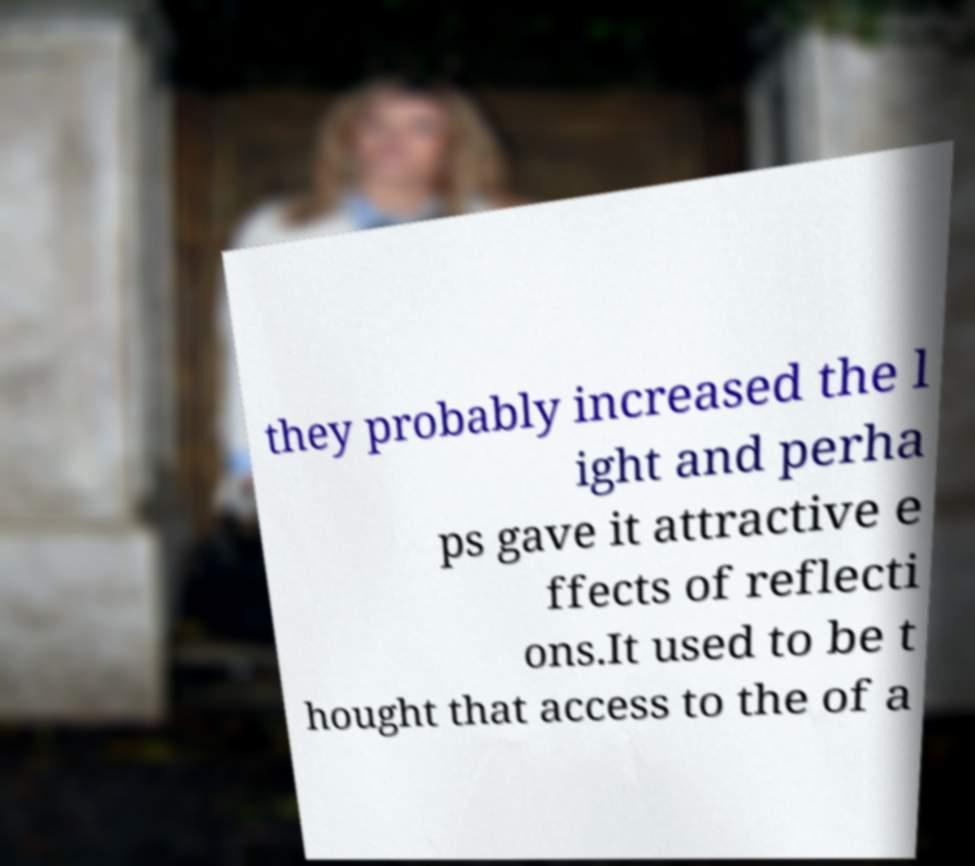Can you read and provide the text displayed in the image?This photo seems to have some interesting text. Can you extract and type it out for me? they probably increased the l ight and perha ps gave it attractive e ffects of reflecti ons.It used to be t hought that access to the of a 